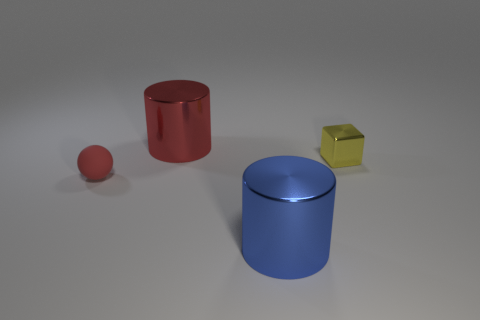What is the apparent size relationship between the objects depicted? The objects are arranged in a descending size order from left to right: the large blue cylinder is the biggest, followed by the red cylinder which is medium-sized, and the smallest objects are the yellow cube and the small red sphere. 